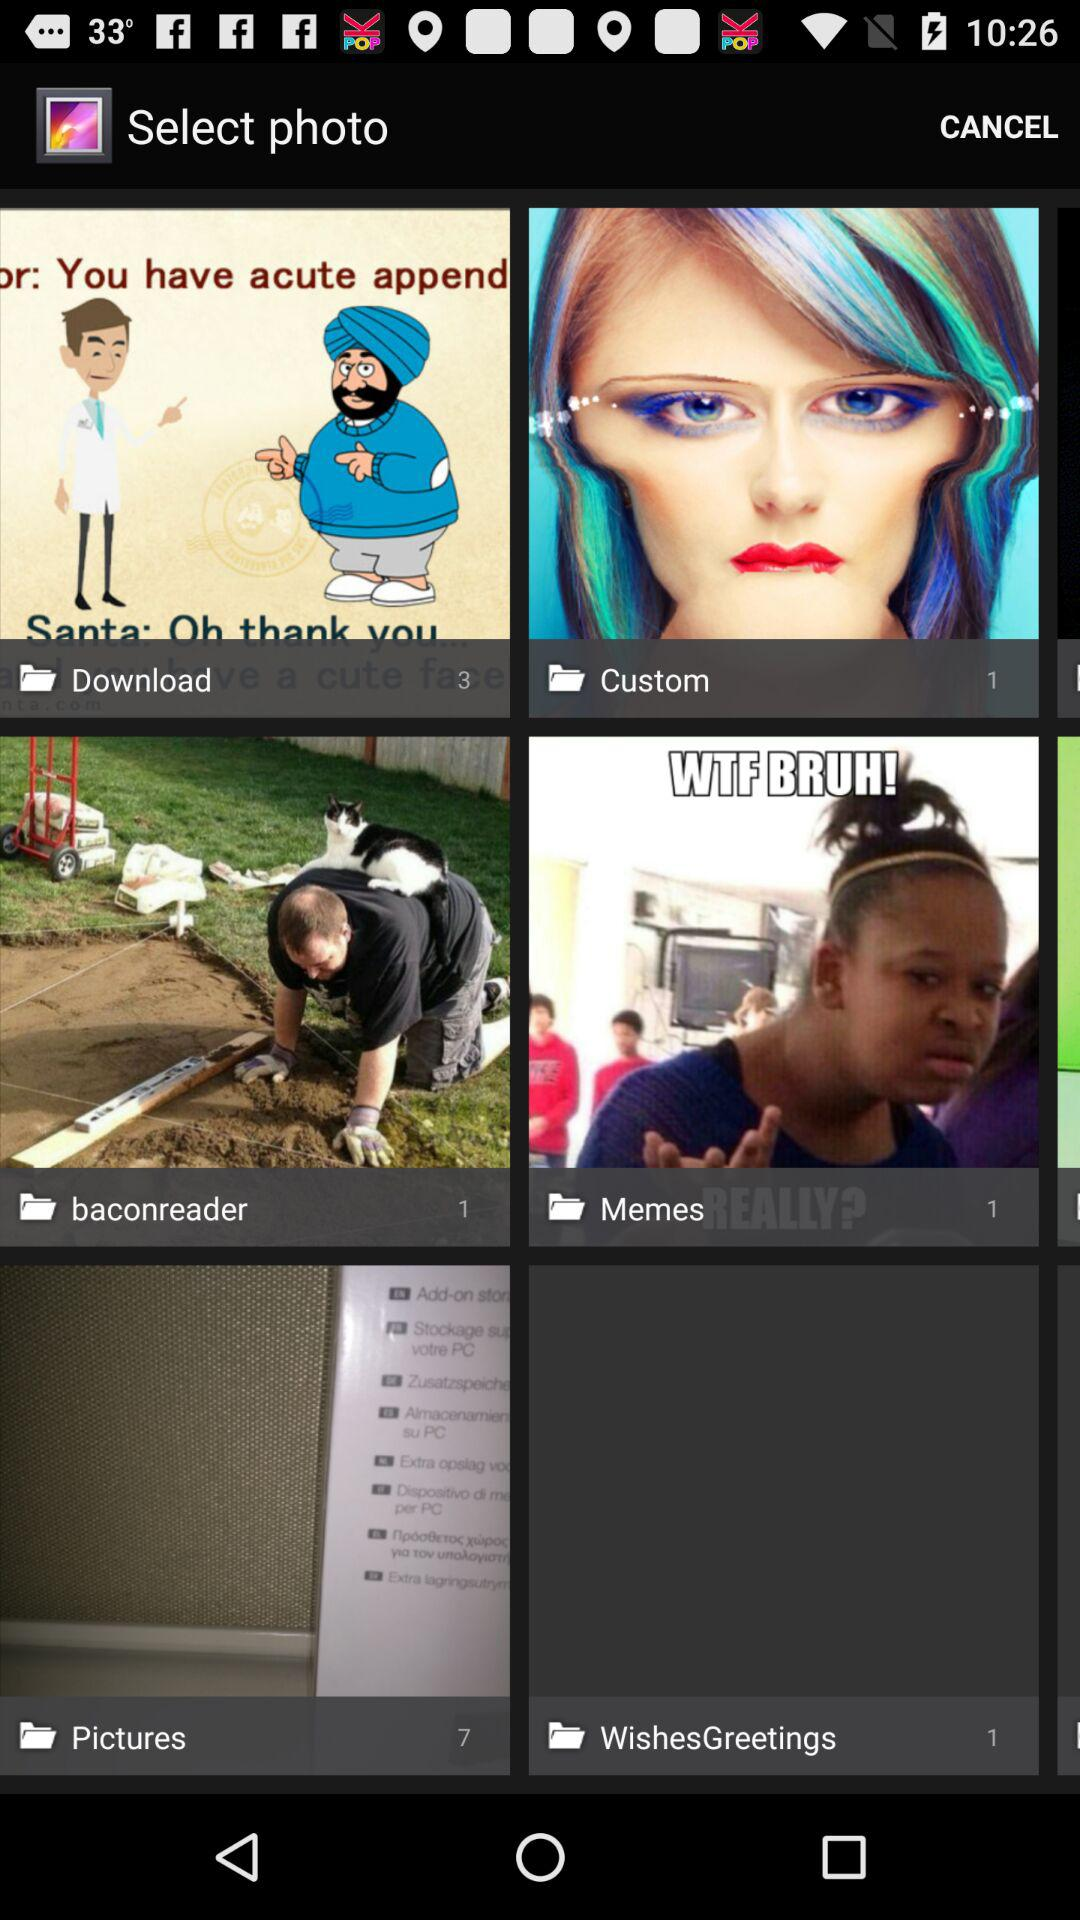What is the number of pictures in the custom folder? The number of pictures in the custom folder is 1. 